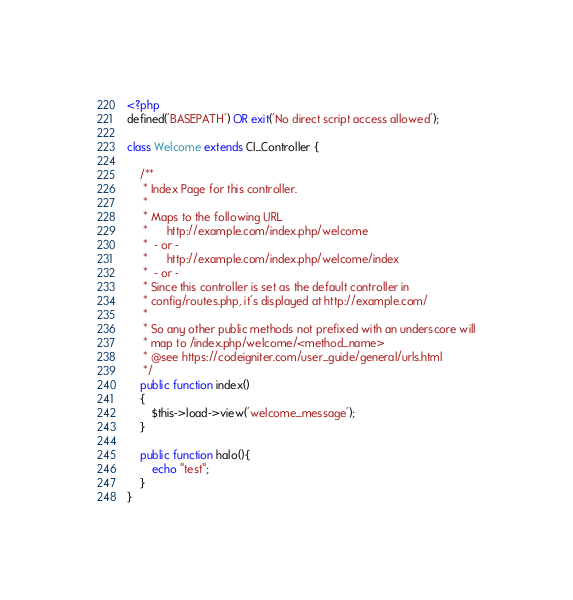<code> <loc_0><loc_0><loc_500><loc_500><_PHP_><?php
defined('BASEPATH') OR exit('No direct script access allowed');

class Welcome extends CI_Controller {

	/**
	 * Index Page for this controller.
	 *
	 * Maps to the following URL
	 * 		http://example.com/index.php/welcome
	 *	- or -
	 * 		http://example.com/index.php/welcome/index
	 *	- or -
	 * Since this controller is set as the default controller in
	 * config/routes.php, it's displayed at http://example.com/
	 *
	 * So any other public methods not prefixed with an underscore will
	 * map to /index.php/welcome/<method_name>
	 * @see https://codeigniter.com/user_guide/general/urls.html
	 */
	public function index()
	{
		$this->load->view('welcome_message');
	}

	public function halo(){
		echo "test";
	}
}
</code> 